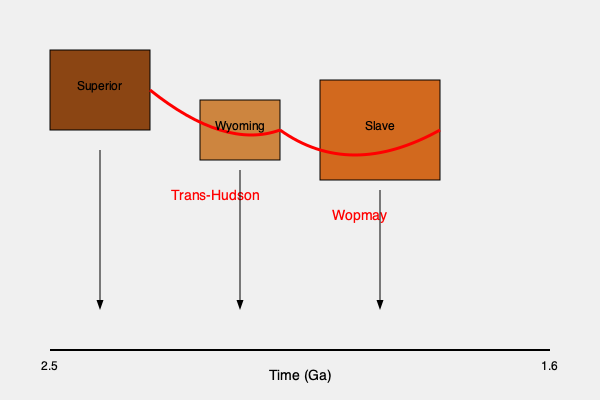Analyze the continental reconstruction diagram of proto-North America during the Paleoproterozoic era. Which major orogenic events are depicted, and how did they contribute to the assembly of the North American craton? To answer this question, let's analyze the diagram step-by-step:

1. Time frame: The diagram shows continental reconstructions from 2.5 Ga to 1.6 Ga, which corresponds to the Paleoproterozoic era.

2. Continental blocks: Three major continental blocks are depicted:
   a) Superior craton (largest, leftmost block)
   b) Wyoming craton (middle block)
   c) Slave craton (rightmost block)

3. Collision zones: Two major collision zones are shown in red:
   a) Between Superior and Wyoming cratons
   b) Between Wyoming and Slave cratons

4. Orogenic events:
   a) Trans-Hudson Orogeny: This is labeled between the Superior and Wyoming cratons. It represents the collision of these two continental blocks.
   b) Wopmay Orogeny: This is labeled between the Wyoming and Slave cratons, indicating the collision between these blocks.

5. Contribution to North American craton assembly:
   a) The Trans-Hudson Orogeny (circa 1.9-1.8 Ga) was a major mountain-building event that joined the Superior and Wyoming cratons, forming the core of the North American continent.
   b) The Wopmay Orogeny (circa 1.9 Ga) resulted in the accretion of the Slave craton to the growing North American continent.

6. Significance:
   These orogenic events were crucial in the assembly of the North American craton, also known as Laurentia. They represent the collision and suturing of previously separate continental blocks, leading to the formation of a larger, more stable continental mass.

7. Mountain-building processes:
   The collision zones (red lines) indicate areas of crustal thickening, metamorphism, and deformation. These processes would have resulted in the formation of mountain ranges along the suture zones between the colliding cratons.

In summary, the diagram illustrates how the Superior, Wyoming, and Slave cratons collided during the Paleoproterozoic, with the Trans-Hudson and Wopmay orogenies being the major mountain-building events that contributed to the assembly of the North American craton.
Answer: Trans-Hudson and Wopmay orogenies; joined Superior, Wyoming, and Slave cratons to form proto-North America. 